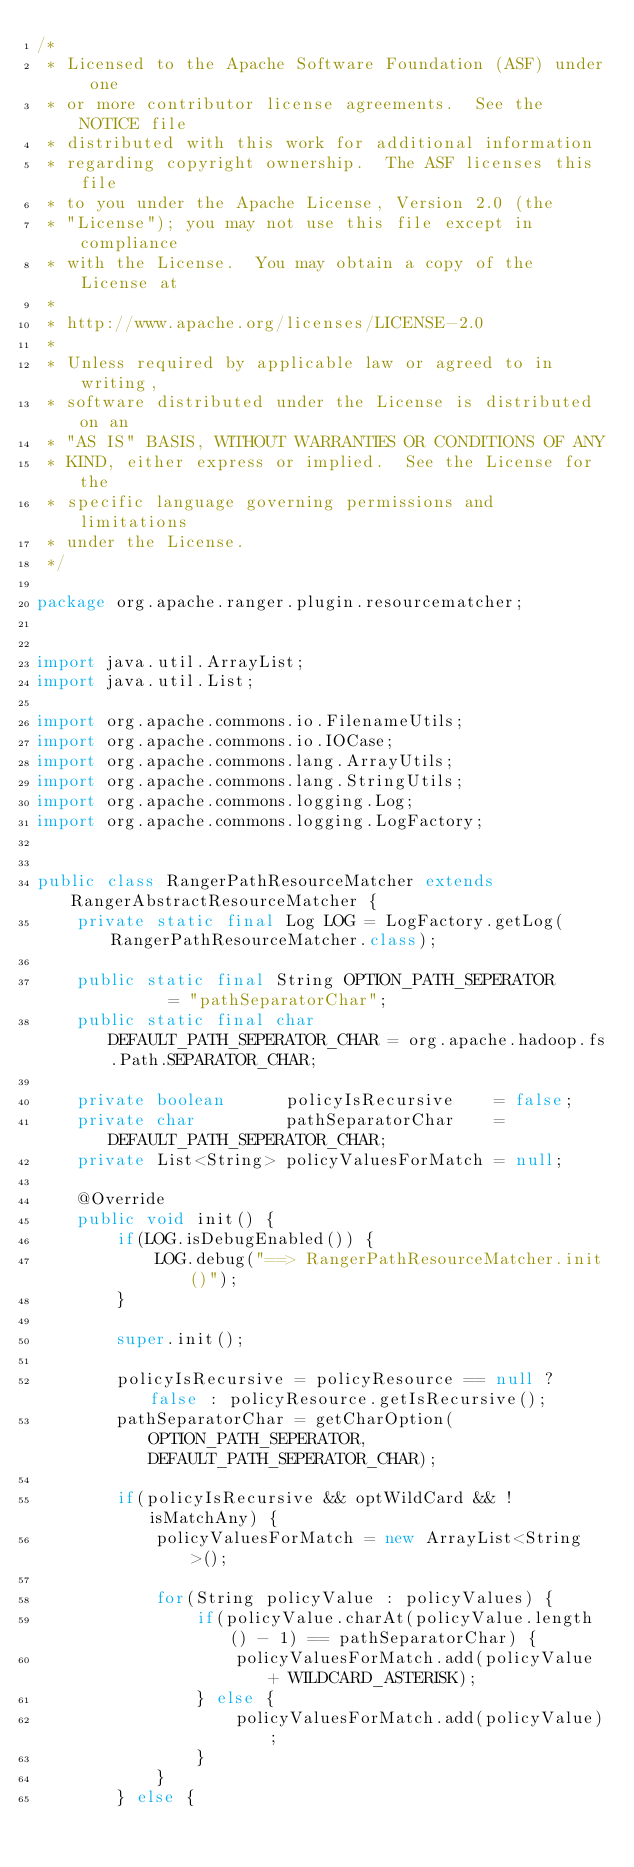Convert code to text. <code><loc_0><loc_0><loc_500><loc_500><_Java_>/*
 * Licensed to the Apache Software Foundation (ASF) under one
 * or more contributor license agreements.  See the NOTICE file
 * distributed with this work for additional information
 * regarding copyright ownership.  The ASF licenses this file
 * to you under the Apache License, Version 2.0 (the
 * "License"); you may not use this file except in compliance
 * with the License.  You may obtain a copy of the License at
 * 
 * http://www.apache.org/licenses/LICENSE-2.0
 * 
 * Unless required by applicable law or agreed to in writing,
 * software distributed under the License is distributed on an
 * "AS IS" BASIS, WITHOUT WARRANTIES OR CONDITIONS OF ANY
 * KIND, either express or implied.  See the License for the
 * specific language governing permissions and limitations
 * under the License.
 */

package org.apache.ranger.plugin.resourcematcher;


import java.util.ArrayList;
import java.util.List;

import org.apache.commons.io.FilenameUtils;
import org.apache.commons.io.IOCase;
import org.apache.commons.lang.ArrayUtils;
import org.apache.commons.lang.StringUtils;
import org.apache.commons.logging.Log;
import org.apache.commons.logging.LogFactory;


public class RangerPathResourceMatcher extends RangerAbstractResourceMatcher {
	private static final Log LOG = LogFactory.getLog(RangerPathResourceMatcher.class);

	public static final String OPTION_PATH_SEPERATOR       = "pathSeparatorChar";
	public static final char   DEFAULT_PATH_SEPERATOR_CHAR = org.apache.hadoop.fs.Path.SEPARATOR_CHAR;

	private boolean      policyIsRecursive    = false;
	private char         pathSeparatorChar    = DEFAULT_PATH_SEPERATOR_CHAR;
	private List<String> policyValuesForMatch = null;

	@Override
	public void init() {
		if(LOG.isDebugEnabled()) {
			LOG.debug("==> RangerPathResourceMatcher.init()");
		}

		super.init();

		policyIsRecursive = policyResource == null ? false : policyResource.getIsRecursive();
		pathSeparatorChar = getCharOption(OPTION_PATH_SEPERATOR, DEFAULT_PATH_SEPERATOR_CHAR);

		if(policyIsRecursive && optWildCard && !isMatchAny) {
			policyValuesForMatch = new ArrayList<String>();

			for(String policyValue : policyValues) {
				if(policyValue.charAt(policyValue.length() - 1) == pathSeparatorChar) {
					policyValuesForMatch.add(policyValue + WILDCARD_ASTERISK);
				} else {
					policyValuesForMatch.add(policyValue);
				}
			}
		} else {</code> 